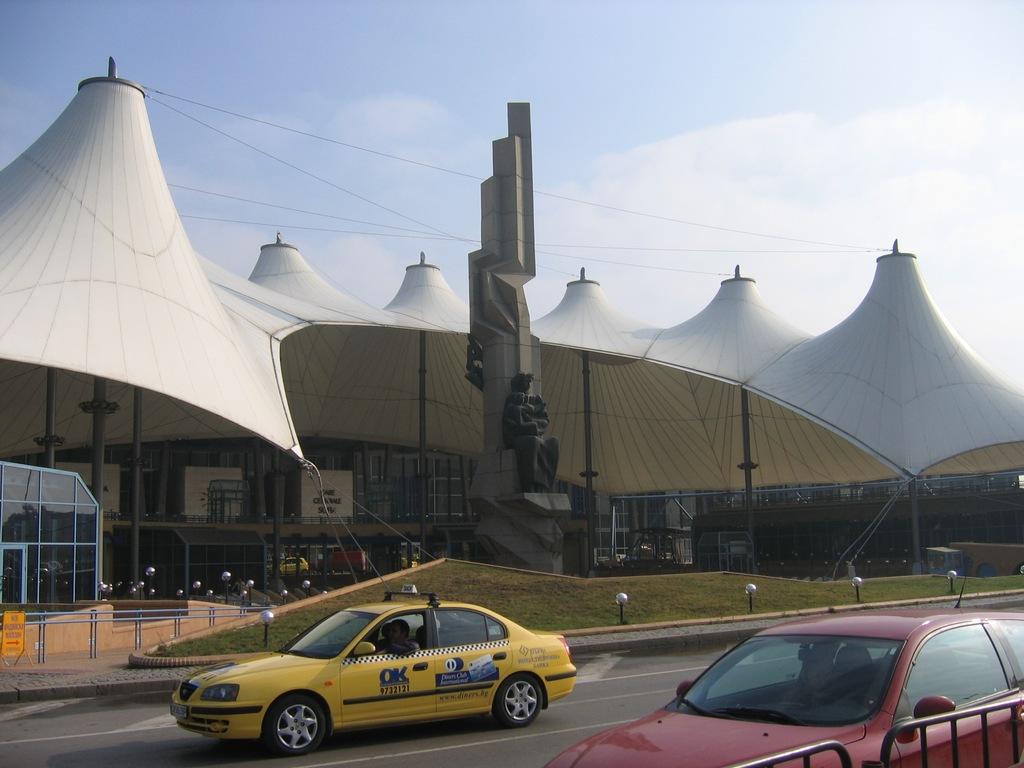What's the name of the taxi comany?
Offer a terse response. Ok. What is the taxi's number?
Your answer should be compact. 9732121. 